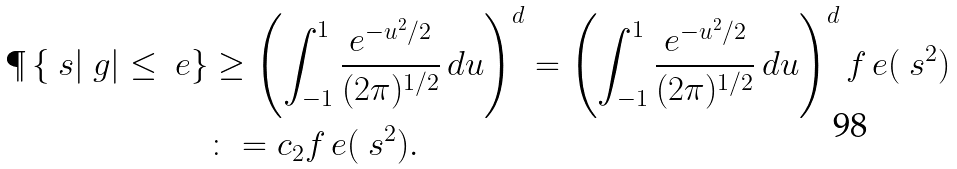<formula> <loc_0><loc_0><loc_500><loc_500>\P \left \{ \ s | \ g | \leq \ e \right \} & \geq \left ( \int _ { - 1 } ^ { 1 } \frac { e ^ { - u ^ { 2 } / 2 } } { ( 2 \pi ) ^ { 1 / 2 } } \, d u \right ) ^ { d } = \left ( \int _ { - 1 } ^ { 1 } \frac { e ^ { - u ^ { 2 } / 2 } } { ( 2 \pi ) ^ { 1 / 2 } } \, d u \right ) ^ { d } f _ { \ } e ( \ s ^ { 2 } ) \\ & \colon = c _ { 2 } f _ { \ } e ( \ s ^ { 2 } ) .</formula> 